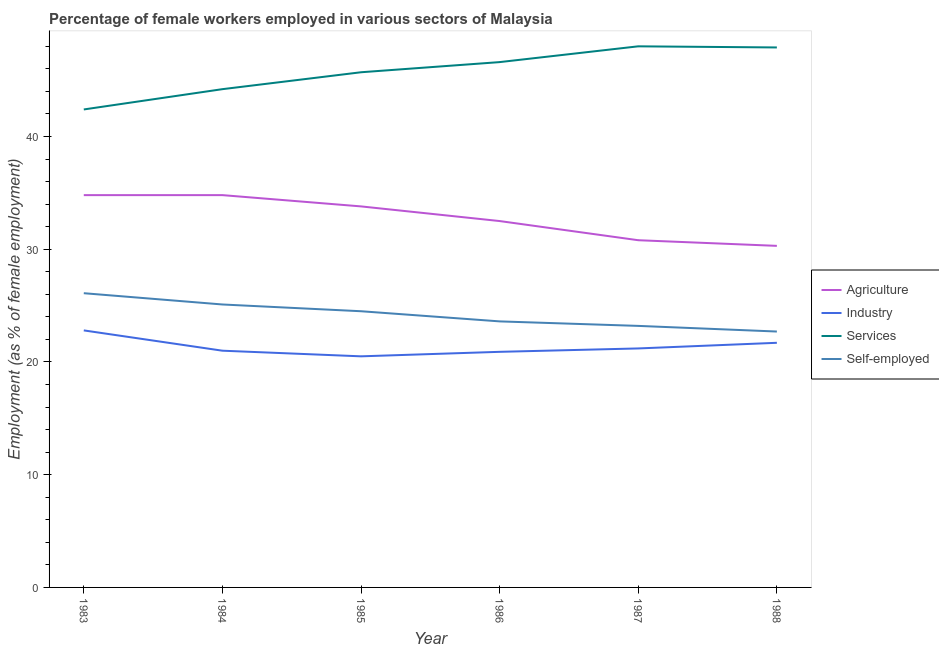How many different coloured lines are there?
Provide a short and direct response. 4. What is the percentage of self employed female workers in 1985?
Provide a short and direct response. 24.5. Across all years, what is the maximum percentage of female workers in agriculture?
Provide a succinct answer. 34.8. Across all years, what is the minimum percentage of female workers in services?
Your answer should be very brief. 42.4. In which year was the percentage of female workers in services minimum?
Give a very brief answer. 1983. What is the total percentage of female workers in services in the graph?
Your answer should be very brief. 274.8. What is the difference between the percentage of female workers in services in 1983 and that in 1984?
Offer a very short reply. -1.8. What is the difference between the percentage of self employed female workers in 1986 and the percentage of female workers in services in 1983?
Provide a succinct answer. -18.8. What is the average percentage of female workers in industry per year?
Your answer should be compact. 21.35. In the year 1983, what is the difference between the percentage of self employed female workers and percentage of female workers in agriculture?
Provide a short and direct response. -8.7. In how many years, is the percentage of female workers in industry greater than 14 %?
Offer a very short reply. 6. What is the ratio of the percentage of female workers in services in 1984 to that in 1985?
Your answer should be very brief. 0.97. What is the difference between the highest and the lowest percentage of female workers in services?
Offer a terse response. 5.6. Is the sum of the percentage of female workers in agriculture in 1984 and 1985 greater than the maximum percentage of self employed female workers across all years?
Provide a succinct answer. Yes. Is the percentage of female workers in services strictly greater than the percentage of self employed female workers over the years?
Keep it short and to the point. Yes. How many lines are there?
Provide a succinct answer. 4. How many years are there in the graph?
Your answer should be very brief. 6. How are the legend labels stacked?
Provide a succinct answer. Vertical. What is the title of the graph?
Ensure brevity in your answer.  Percentage of female workers employed in various sectors of Malaysia. What is the label or title of the Y-axis?
Your answer should be compact. Employment (as % of female employment). What is the Employment (as % of female employment) of Agriculture in 1983?
Your response must be concise. 34.8. What is the Employment (as % of female employment) of Industry in 1983?
Give a very brief answer. 22.8. What is the Employment (as % of female employment) of Services in 1983?
Make the answer very short. 42.4. What is the Employment (as % of female employment) in Self-employed in 1983?
Offer a terse response. 26.1. What is the Employment (as % of female employment) in Agriculture in 1984?
Give a very brief answer. 34.8. What is the Employment (as % of female employment) in Industry in 1984?
Keep it short and to the point. 21. What is the Employment (as % of female employment) in Services in 1984?
Provide a short and direct response. 44.2. What is the Employment (as % of female employment) of Self-employed in 1984?
Your answer should be very brief. 25.1. What is the Employment (as % of female employment) of Agriculture in 1985?
Provide a succinct answer. 33.8. What is the Employment (as % of female employment) of Services in 1985?
Make the answer very short. 45.7. What is the Employment (as % of female employment) of Self-employed in 1985?
Provide a succinct answer. 24.5. What is the Employment (as % of female employment) of Agriculture in 1986?
Offer a terse response. 32.5. What is the Employment (as % of female employment) of Industry in 1986?
Make the answer very short. 20.9. What is the Employment (as % of female employment) in Services in 1986?
Keep it short and to the point. 46.6. What is the Employment (as % of female employment) in Self-employed in 1986?
Ensure brevity in your answer.  23.6. What is the Employment (as % of female employment) of Agriculture in 1987?
Provide a succinct answer. 30.8. What is the Employment (as % of female employment) of Industry in 1987?
Your response must be concise. 21.2. What is the Employment (as % of female employment) of Services in 1987?
Give a very brief answer. 48. What is the Employment (as % of female employment) in Self-employed in 1987?
Offer a terse response. 23.2. What is the Employment (as % of female employment) of Agriculture in 1988?
Offer a terse response. 30.3. What is the Employment (as % of female employment) in Industry in 1988?
Offer a very short reply. 21.7. What is the Employment (as % of female employment) in Services in 1988?
Ensure brevity in your answer.  47.9. What is the Employment (as % of female employment) in Self-employed in 1988?
Your response must be concise. 22.7. Across all years, what is the maximum Employment (as % of female employment) of Agriculture?
Provide a short and direct response. 34.8. Across all years, what is the maximum Employment (as % of female employment) of Industry?
Offer a very short reply. 22.8. Across all years, what is the maximum Employment (as % of female employment) in Services?
Offer a very short reply. 48. Across all years, what is the maximum Employment (as % of female employment) of Self-employed?
Give a very brief answer. 26.1. Across all years, what is the minimum Employment (as % of female employment) of Agriculture?
Provide a short and direct response. 30.3. Across all years, what is the minimum Employment (as % of female employment) of Services?
Keep it short and to the point. 42.4. Across all years, what is the minimum Employment (as % of female employment) in Self-employed?
Ensure brevity in your answer.  22.7. What is the total Employment (as % of female employment) of Agriculture in the graph?
Ensure brevity in your answer.  197. What is the total Employment (as % of female employment) in Industry in the graph?
Keep it short and to the point. 128.1. What is the total Employment (as % of female employment) in Services in the graph?
Offer a very short reply. 274.8. What is the total Employment (as % of female employment) in Self-employed in the graph?
Your answer should be compact. 145.2. What is the difference between the Employment (as % of female employment) in Industry in 1983 and that in 1985?
Your answer should be very brief. 2.3. What is the difference between the Employment (as % of female employment) of Self-employed in 1983 and that in 1986?
Your response must be concise. 2.5. What is the difference between the Employment (as % of female employment) of Agriculture in 1983 and that in 1987?
Provide a succinct answer. 4. What is the difference between the Employment (as % of female employment) of Self-employed in 1983 and that in 1987?
Provide a succinct answer. 2.9. What is the difference between the Employment (as % of female employment) of Services in 1983 and that in 1988?
Ensure brevity in your answer.  -5.5. What is the difference between the Employment (as % of female employment) in Industry in 1984 and that in 1985?
Keep it short and to the point. 0.5. What is the difference between the Employment (as % of female employment) in Self-employed in 1984 and that in 1985?
Provide a short and direct response. 0.6. What is the difference between the Employment (as % of female employment) in Agriculture in 1984 and that in 1986?
Provide a short and direct response. 2.3. What is the difference between the Employment (as % of female employment) of Industry in 1984 and that in 1986?
Provide a short and direct response. 0.1. What is the difference between the Employment (as % of female employment) in Services in 1984 and that in 1986?
Provide a succinct answer. -2.4. What is the difference between the Employment (as % of female employment) of Self-employed in 1984 and that in 1986?
Make the answer very short. 1.5. What is the difference between the Employment (as % of female employment) in Industry in 1984 and that in 1987?
Provide a succinct answer. -0.2. What is the difference between the Employment (as % of female employment) of Self-employed in 1984 and that in 1987?
Provide a short and direct response. 1.9. What is the difference between the Employment (as % of female employment) of Agriculture in 1984 and that in 1988?
Ensure brevity in your answer.  4.5. What is the difference between the Employment (as % of female employment) in Industry in 1984 and that in 1988?
Provide a succinct answer. -0.7. What is the difference between the Employment (as % of female employment) in Services in 1984 and that in 1988?
Provide a succinct answer. -3.7. What is the difference between the Employment (as % of female employment) of Self-employed in 1984 and that in 1988?
Provide a short and direct response. 2.4. What is the difference between the Employment (as % of female employment) of Agriculture in 1985 and that in 1986?
Your response must be concise. 1.3. What is the difference between the Employment (as % of female employment) in Self-employed in 1985 and that in 1986?
Give a very brief answer. 0.9. What is the difference between the Employment (as % of female employment) in Agriculture in 1985 and that in 1987?
Offer a terse response. 3. What is the difference between the Employment (as % of female employment) of Services in 1985 and that in 1987?
Offer a very short reply. -2.3. What is the difference between the Employment (as % of female employment) in Agriculture in 1985 and that in 1988?
Ensure brevity in your answer.  3.5. What is the difference between the Employment (as % of female employment) of Agriculture in 1987 and that in 1988?
Your answer should be compact. 0.5. What is the difference between the Employment (as % of female employment) of Agriculture in 1983 and the Employment (as % of female employment) of Industry in 1984?
Offer a very short reply. 13.8. What is the difference between the Employment (as % of female employment) of Agriculture in 1983 and the Employment (as % of female employment) of Services in 1984?
Give a very brief answer. -9.4. What is the difference between the Employment (as % of female employment) of Agriculture in 1983 and the Employment (as % of female employment) of Self-employed in 1984?
Give a very brief answer. 9.7. What is the difference between the Employment (as % of female employment) of Industry in 1983 and the Employment (as % of female employment) of Services in 1984?
Your answer should be compact. -21.4. What is the difference between the Employment (as % of female employment) of Industry in 1983 and the Employment (as % of female employment) of Self-employed in 1984?
Offer a very short reply. -2.3. What is the difference between the Employment (as % of female employment) of Services in 1983 and the Employment (as % of female employment) of Self-employed in 1984?
Keep it short and to the point. 17.3. What is the difference between the Employment (as % of female employment) in Agriculture in 1983 and the Employment (as % of female employment) in Self-employed in 1985?
Give a very brief answer. 10.3. What is the difference between the Employment (as % of female employment) in Industry in 1983 and the Employment (as % of female employment) in Services in 1985?
Your answer should be compact. -22.9. What is the difference between the Employment (as % of female employment) of Industry in 1983 and the Employment (as % of female employment) of Self-employed in 1985?
Ensure brevity in your answer.  -1.7. What is the difference between the Employment (as % of female employment) of Agriculture in 1983 and the Employment (as % of female employment) of Self-employed in 1986?
Offer a terse response. 11.2. What is the difference between the Employment (as % of female employment) of Industry in 1983 and the Employment (as % of female employment) of Services in 1986?
Your response must be concise. -23.8. What is the difference between the Employment (as % of female employment) of Agriculture in 1983 and the Employment (as % of female employment) of Industry in 1987?
Your answer should be very brief. 13.6. What is the difference between the Employment (as % of female employment) of Agriculture in 1983 and the Employment (as % of female employment) of Services in 1987?
Your answer should be very brief. -13.2. What is the difference between the Employment (as % of female employment) of Agriculture in 1983 and the Employment (as % of female employment) of Self-employed in 1987?
Provide a succinct answer. 11.6. What is the difference between the Employment (as % of female employment) in Industry in 1983 and the Employment (as % of female employment) in Services in 1987?
Your response must be concise. -25.2. What is the difference between the Employment (as % of female employment) in Agriculture in 1983 and the Employment (as % of female employment) in Services in 1988?
Keep it short and to the point. -13.1. What is the difference between the Employment (as % of female employment) of Industry in 1983 and the Employment (as % of female employment) of Services in 1988?
Ensure brevity in your answer.  -25.1. What is the difference between the Employment (as % of female employment) in Industry in 1983 and the Employment (as % of female employment) in Self-employed in 1988?
Provide a succinct answer. 0.1. What is the difference between the Employment (as % of female employment) in Services in 1983 and the Employment (as % of female employment) in Self-employed in 1988?
Keep it short and to the point. 19.7. What is the difference between the Employment (as % of female employment) in Industry in 1984 and the Employment (as % of female employment) in Services in 1985?
Keep it short and to the point. -24.7. What is the difference between the Employment (as % of female employment) of Industry in 1984 and the Employment (as % of female employment) of Self-employed in 1985?
Offer a terse response. -3.5. What is the difference between the Employment (as % of female employment) of Services in 1984 and the Employment (as % of female employment) of Self-employed in 1985?
Your response must be concise. 19.7. What is the difference between the Employment (as % of female employment) in Agriculture in 1984 and the Employment (as % of female employment) in Services in 1986?
Ensure brevity in your answer.  -11.8. What is the difference between the Employment (as % of female employment) in Agriculture in 1984 and the Employment (as % of female employment) in Self-employed in 1986?
Offer a very short reply. 11.2. What is the difference between the Employment (as % of female employment) in Industry in 1984 and the Employment (as % of female employment) in Services in 1986?
Make the answer very short. -25.6. What is the difference between the Employment (as % of female employment) of Industry in 1984 and the Employment (as % of female employment) of Self-employed in 1986?
Give a very brief answer. -2.6. What is the difference between the Employment (as % of female employment) in Services in 1984 and the Employment (as % of female employment) in Self-employed in 1986?
Give a very brief answer. 20.6. What is the difference between the Employment (as % of female employment) of Agriculture in 1984 and the Employment (as % of female employment) of Industry in 1987?
Ensure brevity in your answer.  13.6. What is the difference between the Employment (as % of female employment) in Agriculture in 1984 and the Employment (as % of female employment) in Services in 1987?
Ensure brevity in your answer.  -13.2. What is the difference between the Employment (as % of female employment) of Agriculture in 1984 and the Employment (as % of female employment) of Self-employed in 1987?
Keep it short and to the point. 11.6. What is the difference between the Employment (as % of female employment) of Agriculture in 1984 and the Employment (as % of female employment) of Services in 1988?
Your answer should be very brief. -13.1. What is the difference between the Employment (as % of female employment) of Agriculture in 1984 and the Employment (as % of female employment) of Self-employed in 1988?
Offer a very short reply. 12.1. What is the difference between the Employment (as % of female employment) of Industry in 1984 and the Employment (as % of female employment) of Services in 1988?
Provide a succinct answer. -26.9. What is the difference between the Employment (as % of female employment) in Services in 1984 and the Employment (as % of female employment) in Self-employed in 1988?
Offer a very short reply. 21.5. What is the difference between the Employment (as % of female employment) of Agriculture in 1985 and the Employment (as % of female employment) of Self-employed in 1986?
Offer a terse response. 10.2. What is the difference between the Employment (as % of female employment) in Industry in 1985 and the Employment (as % of female employment) in Services in 1986?
Your response must be concise. -26.1. What is the difference between the Employment (as % of female employment) of Services in 1985 and the Employment (as % of female employment) of Self-employed in 1986?
Offer a terse response. 22.1. What is the difference between the Employment (as % of female employment) in Agriculture in 1985 and the Employment (as % of female employment) in Industry in 1987?
Ensure brevity in your answer.  12.6. What is the difference between the Employment (as % of female employment) of Agriculture in 1985 and the Employment (as % of female employment) of Services in 1987?
Your answer should be very brief. -14.2. What is the difference between the Employment (as % of female employment) of Agriculture in 1985 and the Employment (as % of female employment) of Self-employed in 1987?
Keep it short and to the point. 10.6. What is the difference between the Employment (as % of female employment) in Industry in 1985 and the Employment (as % of female employment) in Services in 1987?
Make the answer very short. -27.5. What is the difference between the Employment (as % of female employment) of Industry in 1985 and the Employment (as % of female employment) of Self-employed in 1987?
Give a very brief answer. -2.7. What is the difference between the Employment (as % of female employment) in Services in 1985 and the Employment (as % of female employment) in Self-employed in 1987?
Ensure brevity in your answer.  22.5. What is the difference between the Employment (as % of female employment) of Agriculture in 1985 and the Employment (as % of female employment) of Industry in 1988?
Your response must be concise. 12.1. What is the difference between the Employment (as % of female employment) in Agriculture in 1985 and the Employment (as % of female employment) in Services in 1988?
Provide a short and direct response. -14.1. What is the difference between the Employment (as % of female employment) in Industry in 1985 and the Employment (as % of female employment) in Services in 1988?
Your answer should be compact. -27.4. What is the difference between the Employment (as % of female employment) in Industry in 1985 and the Employment (as % of female employment) in Self-employed in 1988?
Your answer should be compact. -2.2. What is the difference between the Employment (as % of female employment) of Services in 1985 and the Employment (as % of female employment) of Self-employed in 1988?
Give a very brief answer. 23. What is the difference between the Employment (as % of female employment) of Agriculture in 1986 and the Employment (as % of female employment) of Services in 1987?
Provide a short and direct response. -15.5. What is the difference between the Employment (as % of female employment) of Industry in 1986 and the Employment (as % of female employment) of Services in 1987?
Provide a short and direct response. -27.1. What is the difference between the Employment (as % of female employment) in Industry in 1986 and the Employment (as % of female employment) in Self-employed in 1987?
Provide a short and direct response. -2.3. What is the difference between the Employment (as % of female employment) in Services in 1986 and the Employment (as % of female employment) in Self-employed in 1987?
Keep it short and to the point. 23.4. What is the difference between the Employment (as % of female employment) of Agriculture in 1986 and the Employment (as % of female employment) of Services in 1988?
Your response must be concise. -15.4. What is the difference between the Employment (as % of female employment) in Industry in 1986 and the Employment (as % of female employment) in Self-employed in 1988?
Your response must be concise. -1.8. What is the difference between the Employment (as % of female employment) of Services in 1986 and the Employment (as % of female employment) of Self-employed in 1988?
Your answer should be compact. 23.9. What is the difference between the Employment (as % of female employment) of Agriculture in 1987 and the Employment (as % of female employment) of Services in 1988?
Offer a very short reply. -17.1. What is the difference between the Employment (as % of female employment) in Agriculture in 1987 and the Employment (as % of female employment) in Self-employed in 1988?
Your answer should be compact. 8.1. What is the difference between the Employment (as % of female employment) of Industry in 1987 and the Employment (as % of female employment) of Services in 1988?
Offer a very short reply. -26.7. What is the difference between the Employment (as % of female employment) of Industry in 1987 and the Employment (as % of female employment) of Self-employed in 1988?
Make the answer very short. -1.5. What is the difference between the Employment (as % of female employment) in Services in 1987 and the Employment (as % of female employment) in Self-employed in 1988?
Your answer should be compact. 25.3. What is the average Employment (as % of female employment) in Agriculture per year?
Offer a terse response. 32.83. What is the average Employment (as % of female employment) of Industry per year?
Provide a succinct answer. 21.35. What is the average Employment (as % of female employment) of Services per year?
Offer a very short reply. 45.8. What is the average Employment (as % of female employment) of Self-employed per year?
Provide a short and direct response. 24.2. In the year 1983, what is the difference between the Employment (as % of female employment) in Agriculture and Employment (as % of female employment) in Industry?
Your response must be concise. 12. In the year 1983, what is the difference between the Employment (as % of female employment) in Agriculture and Employment (as % of female employment) in Self-employed?
Keep it short and to the point. 8.7. In the year 1983, what is the difference between the Employment (as % of female employment) in Industry and Employment (as % of female employment) in Services?
Your response must be concise. -19.6. In the year 1983, what is the difference between the Employment (as % of female employment) in Services and Employment (as % of female employment) in Self-employed?
Make the answer very short. 16.3. In the year 1984, what is the difference between the Employment (as % of female employment) in Agriculture and Employment (as % of female employment) in Services?
Your answer should be compact. -9.4. In the year 1984, what is the difference between the Employment (as % of female employment) of Industry and Employment (as % of female employment) of Services?
Provide a short and direct response. -23.2. In the year 1985, what is the difference between the Employment (as % of female employment) in Agriculture and Employment (as % of female employment) in Industry?
Your answer should be compact. 13.3. In the year 1985, what is the difference between the Employment (as % of female employment) of Agriculture and Employment (as % of female employment) of Services?
Offer a very short reply. -11.9. In the year 1985, what is the difference between the Employment (as % of female employment) in Agriculture and Employment (as % of female employment) in Self-employed?
Give a very brief answer. 9.3. In the year 1985, what is the difference between the Employment (as % of female employment) in Industry and Employment (as % of female employment) in Services?
Give a very brief answer. -25.2. In the year 1985, what is the difference between the Employment (as % of female employment) in Services and Employment (as % of female employment) in Self-employed?
Your response must be concise. 21.2. In the year 1986, what is the difference between the Employment (as % of female employment) in Agriculture and Employment (as % of female employment) in Industry?
Keep it short and to the point. 11.6. In the year 1986, what is the difference between the Employment (as % of female employment) in Agriculture and Employment (as % of female employment) in Services?
Ensure brevity in your answer.  -14.1. In the year 1986, what is the difference between the Employment (as % of female employment) of Industry and Employment (as % of female employment) of Services?
Give a very brief answer. -25.7. In the year 1986, what is the difference between the Employment (as % of female employment) in Industry and Employment (as % of female employment) in Self-employed?
Offer a terse response. -2.7. In the year 1987, what is the difference between the Employment (as % of female employment) in Agriculture and Employment (as % of female employment) in Services?
Make the answer very short. -17.2. In the year 1987, what is the difference between the Employment (as % of female employment) in Agriculture and Employment (as % of female employment) in Self-employed?
Keep it short and to the point. 7.6. In the year 1987, what is the difference between the Employment (as % of female employment) of Industry and Employment (as % of female employment) of Services?
Your answer should be very brief. -26.8. In the year 1987, what is the difference between the Employment (as % of female employment) in Industry and Employment (as % of female employment) in Self-employed?
Your answer should be very brief. -2. In the year 1987, what is the difference between the Employment (as % of female employment) in Services and Employment (as % of female employment) in Self-employed?
Your response must be concise. 24.8. In the year 1988, what is the difference between the Employment (as % of female employment) of Agriculture and Employment (as % of female employment) of Services?
Give a very brief answer. -17.6. In the year 1988, what is the difference between the Employment (as % of female employment) in Agriculture and Employment (as % of female employment) in Self-employed?
Your response must be concise. 7.6. In the year 1988, what is the difference between the Employment (as % of female employment) of Industry and Employment (as % of female employment) of Services?
Make the answer very short. -26.2. In the year 1988, what is the difference between the Employment (as % of female employment) of Services and Employment (as % of female employment) of Self-employed?
Ensure brevity in your answer.  25.2. What is the ratio of the Employment (as % of female employment) in Agriculture in 1983 to that in 1984?
Your answer should be very brief. 1. What is the ratio of the Employment (as % of female employment) of Industry in 1983 to that in 1984?
Your answer should be compact. 1.09. What is the ratio of the Employment (as % of female employment) of Services in 1983 to that in 1984?
Ensure brevity in your answer.  0.96. What is the ratio of the Employment (as % of female employment) of Self-employed in 1983 to that in 1984?
Your answer should be very brief. 1.04. What is the ratio of the Employment (as % of female employment) in Agriculture in 1983 to that in 1985?
Offer a very short reply. 1.03. What is the ratio of the Employment (as % of female employment) in Industry in 1983 to that in 1985?
Offer a very short reply. 1.11. What is the ratio of the Employment (as % of female employment) in Services in 1983 to that in 1985?
Offer a very short reply. 0.93. What is the ratio of the Employment (as % of female employment) of Self-employed in 1983 to that in 1985?
Offer a terse response. 1.07. What is the ratio of the Employment (as % of female employment) in Agriculture in 1983 to that in 1986?
Keep it short and to the point. 1.07. What is the ratio of the Employment (as % of female employment) of Services in 1983 to that in 1986?
Your answer should be compact. 0.91. What is the ratio of the Employment (as % of female employment) of Self-employed in 1983 to that in 1986?
Give a very brief answer. 1.11. What is the ratio of the Employment (as % of female employment) in Agriculture in 1983 to that in 1987?
Provide a succinct answer. 1.13. What is the ratio of the Employment (as % of female employment) in Industry in 1983 to that in 1987?
Keep it short and to the point. 1.08. What is the ratio of the Employment (as % of female employment) of Services in 1983 to that in 1987?
Provide a succinct answer. 0.88. What is the ratio of the Employment (as % of female employment) of Agriculture in 1983 to that in 1988?
Your answer should be compact. 1.15. What is the ratio of the Employment (as % of female employment) of Industry in 1983 to that in 1988?
Make the answer very short. 1.05. What is the ratio of the Employment (as % of female employment) of Services in 1983 to that in 1988?
Your response must be concise. 0.89. What is the ratio of the Employment (as % of female employment) of Self-employed in 1983 to that in 1988?
Your answer should be compact. 1.15. What is the ratio of the Employment (as % of female employment) in Agriculture in 1984 to that in 1985?
Your answer should be compact. 1.03. What is the ratio of the Employment (as % of female employment) of Industry in 1984 to that in 1985?
Offer a terse response. 1.02. What is the ratio of the Employment (as % of female employment) of Services in 1984 to that in 1985?
Provide a short and direct response. 0.97. What is the ratio of the Employment (as % of female employment) in Self-employed in 1984 to that in 1985?
Make the answer very short. 1.02. What is the ratio of the Employment (as % of female employment) of Agriculture in 1984 to that in 1986?
Provide a short and direct response. 1.07. What is the ratio of the Employment (as % of female employment) of Industry in 1984 to that in 1986?
Make the answer very short. 1. What is the ratio of the Employment (as % of female employment) of Services in 1984 to that in 1986?
Provide a succinct answer. 0.95. What is the ratio of the Employment (as % of female employment) in Self-employed in 1984 to that in 1986?
Make the answer very short. 1.06. What is the ratio of the Employment (as % of female employment) in Agriculture in 1984 to that in 1987?
Keep it short and to the point. 1.13. What is the ratio of the Employment (as % of female employment) of Industry in 1984 to that in 1987?
Your answer should be compact. 0.99. What is the ratio of the Employment (as % of female employment) of Services in 1984 to that in 1987?
Keep it short and to the point. 0.92. What is the ratio of the Employment (as % of female employment) in Self-employed in 1984 to that in 1987?
Make the answer very short. 1.08. What is the ratio of the Employment (as % of female employment) of Agriculture in 1984 to that in 1988?
Provide a succinct answer. 1.15. What is the ratio of the Employment (as % of female employment) in Services in 1984 to that in 1988?
Give a very brief answer. 0.92. What is the ratio of the Employment (as % of female employment) of Self-employed in 1984 to that in 1988?
Ensure brevity in your answer.  1.11. What is the ratio of the Employment (as % of female employment) of Agriculture in 1985 to that in 1986?
Provide a succinct answer. 1.04. What is the ratio of the Employment (as % of female employment) in Industry in 1985 to that in 1986?
Your response must be concise. 0.98. What is the ratio of the Employment (as % of female employment) in Services in 1985 to that in 1986?
Ensure brevity in your answer.  0.98. What is the ratio of the Employment (as % of female employment) in Self-employed in 1985 to that in 1986?
Provide a succinct answer. 1.04. What is the ratio of the Employment (as % of female employment) in Agriculture in 1985 to that in 1987?
Provide a succinct answer. 1.1. What is the ratio of the Employment (as % of female employment) of Industry in 1985 to that in 1987?
Your response must be concise. 0.97. What is the ratio of the Employment (as % of female employment) in Services in 1985 to that in 1987?
Offer a terse response. 0.95. What is the ratio of the Employment (as % of female employment) in Self-employed in 1985 to that in 1987?
Keep it short and to the point. 1.06. What is the ratio of the Employment (as % of female employment) in Agriculture in 1985 to that in 1988?
Your answer should be compact. 1.12. What is the ratio of the Employment (as % of female employment) of Industry in 1985 to that in 1988?
Provide a short and direct response. 0.94. What is the ratio of the Employment (as % of female employment) in Services in 1985 to that in 1988?
Offer a terse response. 0.95. What is the ratio of the Employment (as % of female employment) in Self-employed in 1985 to that in 1988?
Offer a terse response. 1.08. What is the ratio of the Employment (as % of female employment) of Agriculture in 1986 to that in 1987?
Offer a very short reply. 1.06. What is the ratio of the Employment (as % of female employment) in Industry in 1986 to that in 1987?
Your answer should be very brief. 0.99. What is the ratio of the Employment (as % of female employment) of Services in 1986 to that in 1987?
Provide a succinct answer. 0.97. What is the ratio of the Employment (as % of female employment) of Self-employed in 1986 to that in 1987?
Your answer should be compact. 1.02. What is the ratio of the Employment (as % of female employment) of Agriculture in 1986 to that in 1988?
Provide a short and direct response. 1.07. What is the ratio of the Employment (as % of female employment) in Industry in 1986 to that in 1988?
Offer a terse response. 0.96. What is the ratio of the Employment (as % of female employment) of Services in 1986 to that in 1988?
Offer a terse response. 0.97. What is the ratio of the Employment (as % of female employment) of Self-employed in 1986 to that in 1988?
Provide a short and direct response. 1.04. What is the ratio of the Employment (as % of female employment) in Agriculture in 1987 to that in 1988?
Make the answer very short. 1.02. What is the ratio of the Employment (as % of female employment) in Industry in 1987 to that in 1988?
Make the answer very short. 0.98. What is the ratio of the Employment (as % of female employment) of Services in 1987 to that in 1988?
Your response must be concise. 1. What is the difference between the highest and the second highest Employment (as % of female employment) of Services?
Give a very brief answer. 0.1. What is the difference between the highest and the lowest Employment (as % of female employment) in Agriculture?
Ensure brevity in your answer.  4.5. 